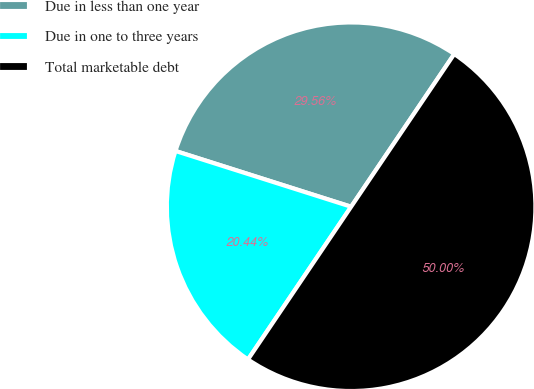Convert chart to OTSL. <chart><loc_0><loc_0><loc_500><loc_500><pie_chart><fcel>Due in less than one year<fcel>Due in one to three years<fcel>Total marketable debt<nl><fcel>29.56%<fcel>20.44%<fcel>50.0%<nl></chart> 